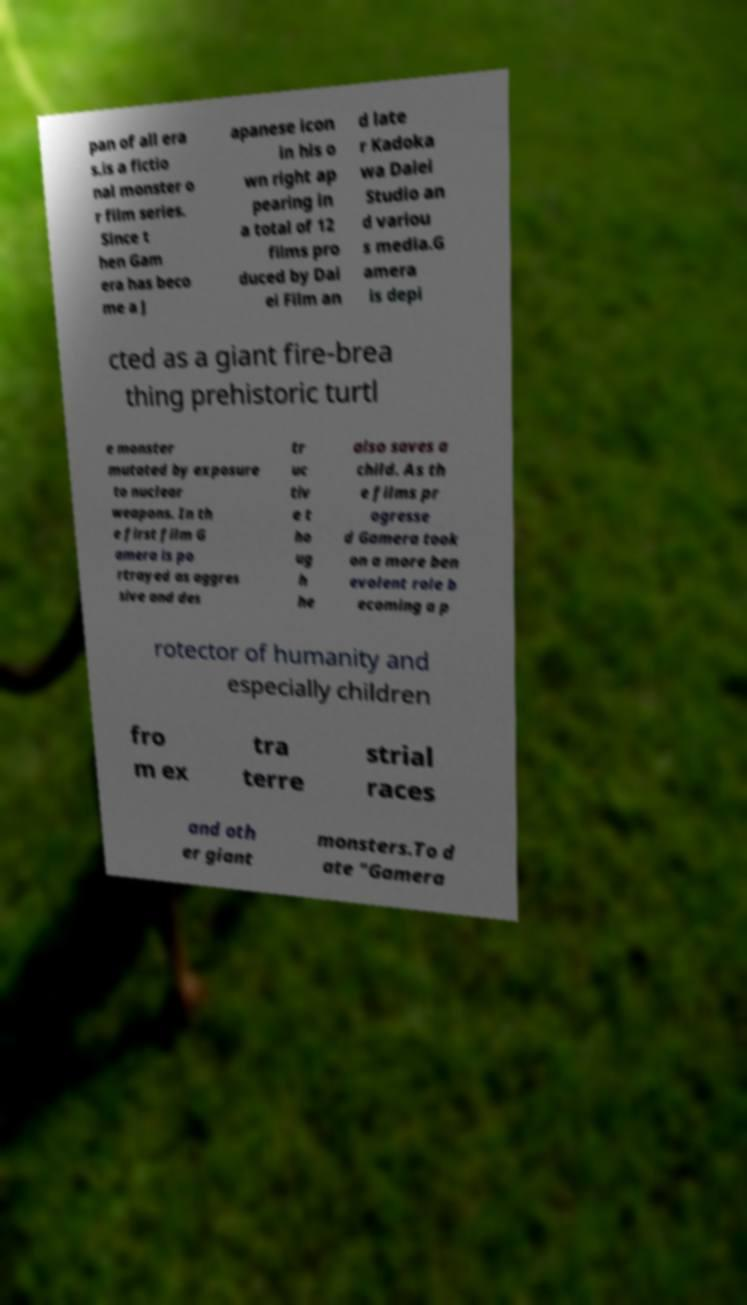Please read and relay the text visible in this image. What does it say? pan of all era s.is a fictio nal monster o r film series. Since t hen Gam era has beco me a J apanese icon in his o wn right ap pearing in a total of 12 films pro duced by Dai ei Film an d late r Kadoka wa Daiei Studio an d variou s media.G amera is depi cted as a giant fire-brea thing prehistoric turtl e monster mutated by exposure to nuclear weapons. In th e first film G amera is po rtrayed as aggres sive and des tr uc tiv e t ho ug h he also saves a child. As th e films pr ogresse d Gamera took on a more ben evolent role b ecoming a p rotector of humanity and especially children fro m ex tra terre strial races and oth er giant monsters.To d ate "Gamera 